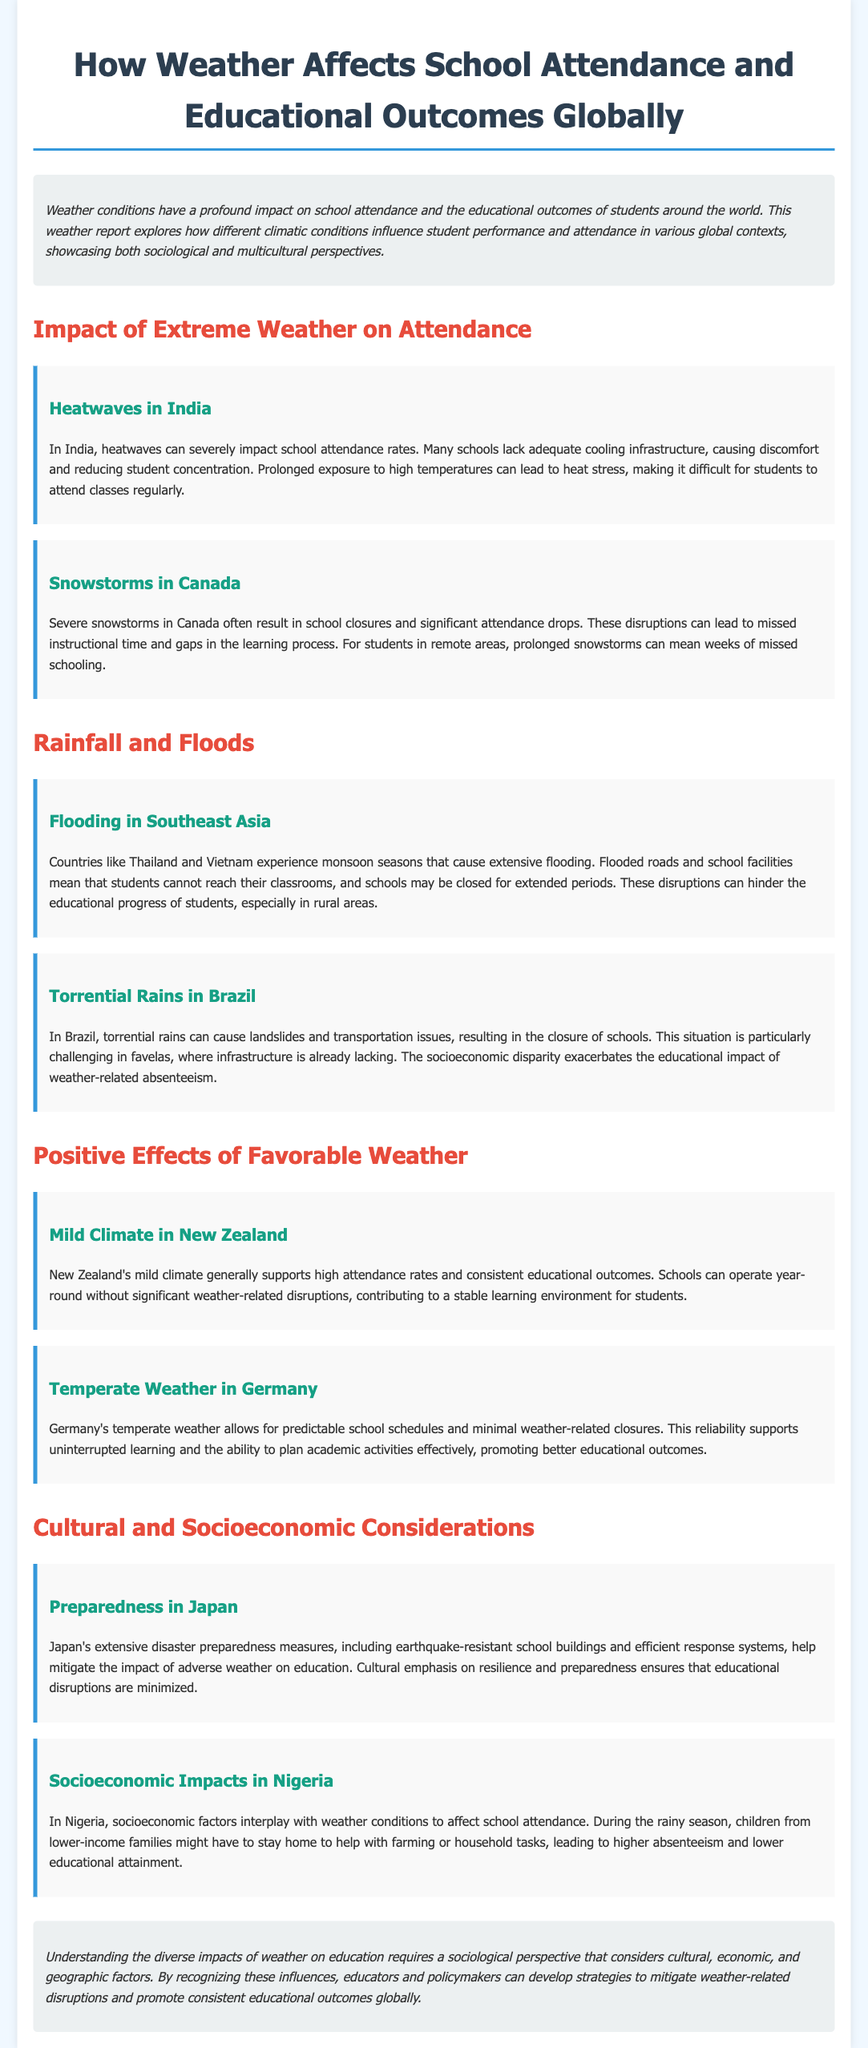What impact do heatwaves have on school attendance in India? The document states that heatwaves can severely impact school attendance rates due to inadequate cooling infrastructure, leading to discomfort and reduced concentration.
Answer: Severe impact What are the consequences of snowstorms in Canada on school attendance? The document mentions that severe snowstorms often result in school closures and significant attendance drops, leading to missed instructional time.
Answer: School closures What challenge do students face during monsoon seasons in Southeast Asia? The document highlights that extensive flooding during monsoon seasons causes flooded roads and school closures, preventing students from reaching classrooms.
Answer: Flooded roads How does New Zealand's climate affect educational outcomes? According to the document, New Zealand's mild climate supports high attendance rates and consistent educational outcomes, allowing schools to operate year-round.
Answer: High attendance rates What does Japan emphasize to mitigate the impact of adverse weather on education? The document states that Japan's extensive disaster preparedness measures help mitigate educational disruptions, focusing on resilience and preparedness.
Answer: Resilience How do socioeconomic factors affect school attendance during the rainy season in Nigeria? The document explains that during the rainy season, children from lower-income families might stay home to help, leading to higher absenteeism and lower educational attainment.
Answer: Higher absenteeism What is the primary focus of the weather report? The introduction outlines that the report explores how weather conditions impact school attendance and educational outcomes from sociological and multicultural perspectives.
Answer: Weather conditions What does Germany's temperate weather allow for in terms of school activities? The document states that Germany's temperate weather allows for predictable school schedules and minimal weather-related closures, supporting uninterrupted learning.
Answer: Predictable school schedules What is the cultural aspect mentioned in the weather report? The document points out that Japan emphasizes disaster preparedness, which includes earthquake-resistant buildings and efficient response systems to minimize disruptions.
Answer: Disaster preparedness 